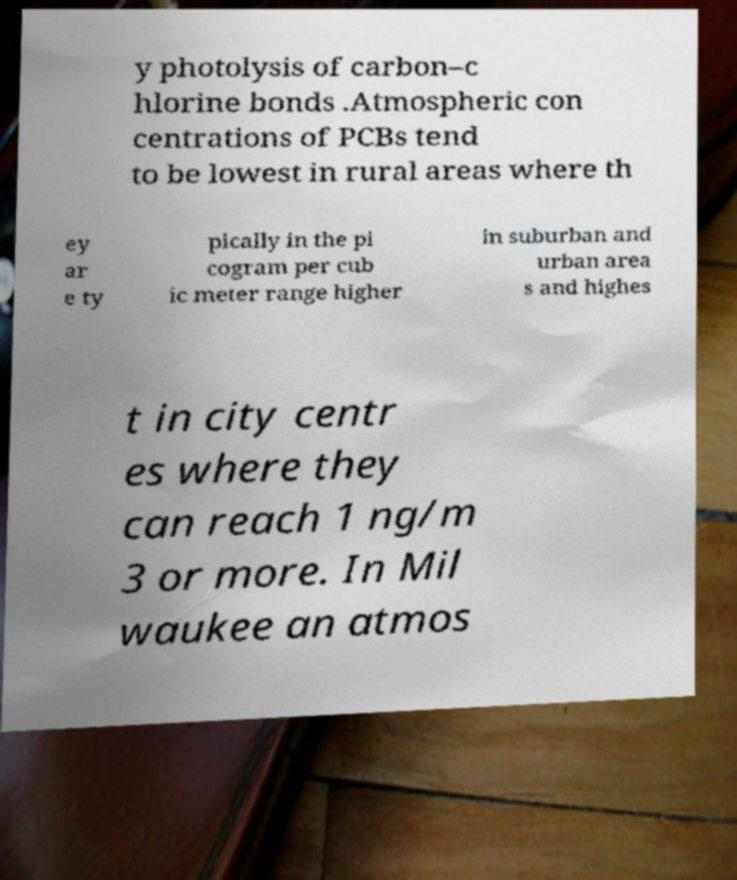I need the written content from this picture converted into text. Can you do that? y photolysis of carbon–c hlorine bonds .Atmospheric con centrations of PCBs tend to be lowest in rural areas where th ey ar e ty pically in the pi cogram per cub ic meter range higher in suburban and urban area s and highes t in city centr es where they can reach 1 ng/m 3 or more. In Mil waukee an atmos 